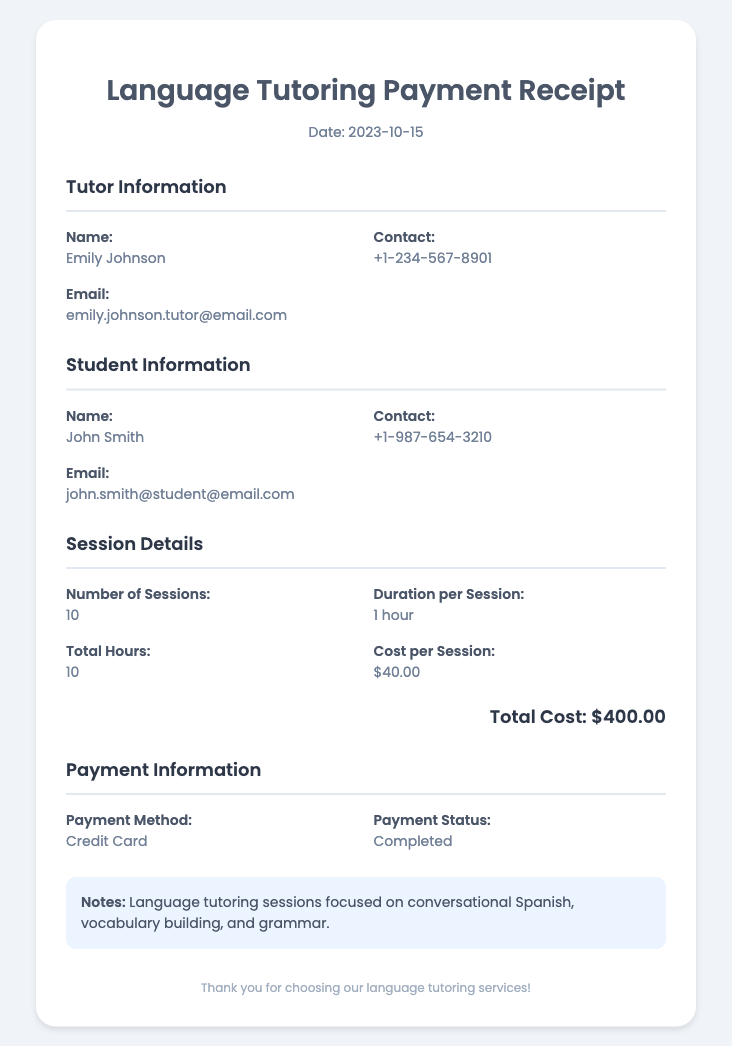What is the date of the receipt? The date of the receipt is stated clearly in the document header.
Answer: 2023-10-15 Who is the tutor? The document lists the tutor's name in the Tutor Information section.
Answer: Emily Johnson What is the total cost of the tutoring sessions? The total cost is calculated based on the number of sessions and cost per session mentioned in the document.
Answer: $400.00 How many total hours were tutored? The document provides a summary of total hours in the Session Details section.
Answer: 10 What is the payment method used? The payment method is specified under the Payment Information section.
Answer: Credit Card How many sessions were conducted? The number of sessions is provided under the Session Details section of the document.
Answer: 10 What is the email of the tutor? The tutor's email can be found in the Tutor Information section of the document.
Answer: emily.johnson.tutor@email.com What is the duration per session? The duration per session is mentioned in the Session Details section.
Answer: 1 hour What is mentioned in the notes about the tutoring sessions? The notes provide additional information about the focus areas of the tutoring sessions.
Answer: Conversational Spanish, vocabulary building, and grammar 